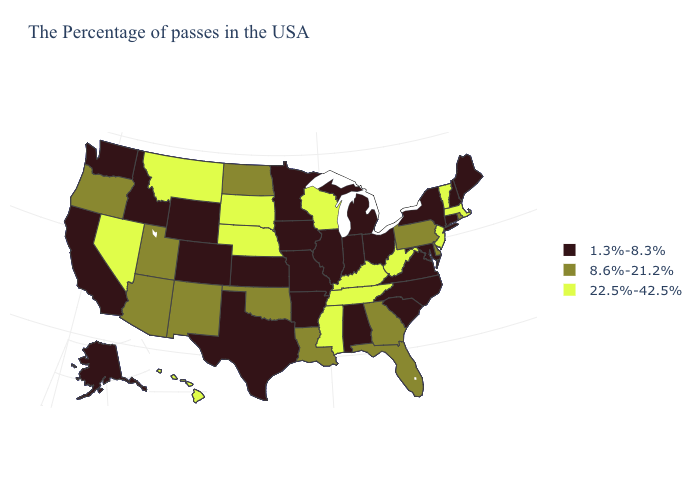Among the states that border Virginia , does Maryland have the highest value?
Concise answer only. No. Name the states that have a value in the range 8.6%-21.2%?
Concise answer only. Rhode Island, Delaware, Pennsylvania, Florida, Georgia, Louisiana, Oklahoma, North Dakota, New Mexico, Utah, Arizona, Oregon. Name the states that have a value in the range 8.6%-21.2%?
Give a very brief answer. Rhode Island, Delaware, Pennsylvania, Florida, Georgia, Louisiana, Oklahoma, North Dakota, New Mexico, Utah, Arizona, Oregon. Does Wyoming have a lower value than Utah?
Answer briefly. Yes. Name the states that have a value in the range 1.3%-8.3%?
Be succinct. Maine, New Hampshire, Connecticut, New York, Maryland, Virginia, North Carolina, South Carolina, Ohio, Michigan, Indiana, Alabama, Illinois, Missouri, Arkansas, Minnesota, Iowa, Kansas, Texas, Wyoming, Colorado, Idaho, California, Washington, Alaska. Which states have the lowest value in the MidWest?
Quick response, please. Ohio, Michigan, Indiana, Illinois, Missouri, Minnesota, Iowa, Kansas. Does Kentucky have the same value as South Dakota?
Quick response, please. Yes. What is the value of Missouri?
Give a very brief answer. 1.3%-8.3%. Name the states that have a value in the range 8.6%-21.2%?
Give a very brief answer. Rhode Island, Delaware, Pennsylvania, Florida, Georgia, Louisiana, Oklahoma, North Dakota, New Mexico, Utah, Arizona, Oregon. Name the states that have a value in the range 8.6%-21.2%?
Answer briefly. Rhode Island, Delaware, Pennsylvania, Florida, Georgia, Louisiana, Oklahoma, North Dakota, New Mexico, Utah, Arizona, Oregon. What is the value of Delaware?
Concise answer only. 8.6%-21.2%. Which states have the lowest value in the USA?
Concise answer only. Maine, New Hampshire, Connecticut, New York, Maryland, Virginia, North Carolina, South Carolina, Ohio, Michigan, Indiana, Alabama, Illinois, Missouri, Arkansas, Minnesota, Iowa, Kansas, Texas, Wyoming, Colorado, Idaho, California, Washington, Alaska. Name the states that have a value in the range 1.3%-8.3%?
Quick response, please. Maine, New Hampshire, Connecticut, New York, Maryland, Virginia, North Carolina, South Carolina, Ohio, Michigan, Indiana, Alabama, Illinois, Missouri, Arkansas, Minnesota, Iowa, Kansas, Texas, Wyoming, Colorado, Idaho, California, Washington, Alaska. What is the lowest value in the West?
Give a very brief answer. 1.3%-8.3%. Name the states that have a value in the range 8.6%-21.2%?
Concise answer only. Rhode Island, Delaware, Pennsylvania, Florida, Georgia, Louisiana, Oklahoma, North Dakota, New Mexico, Utah, Arizona, Oregon. 